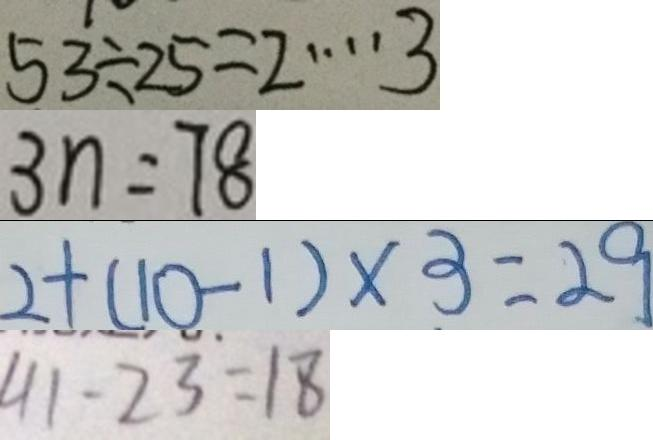<formula> <loc_0><loc_0><loc_500><loc_500>5 3 \div 2 5 = 2 \cdots 3 
 3 n = 7 8 
 2 + ( 1 0 - 1 ) \times 3 = 2 9 
 4 1 - 2 3 = 1 8</formula> 